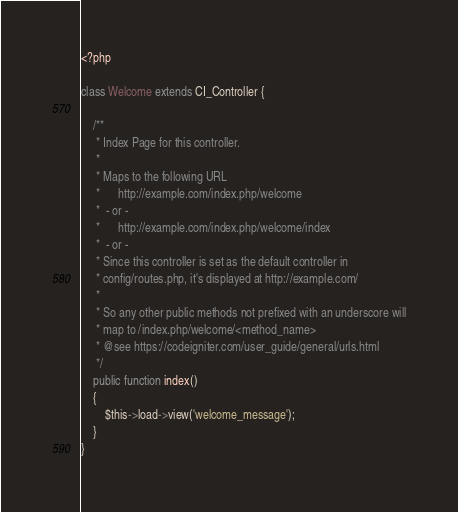<code> <loc_0><loc_0><loc_500><loc_500><_PHP_><?php

class Welcome extends CI_Controller {

	/**
	 * Index Page for this controller.
	 *
	 * Maps to the following URL
	 * 		http://example.com/index.php/welcome
	 *	- or -
	 * 		http://example.com/index.php/welcome/index
	 *	- or -
	 * Since this controller is set as the default controller in
	 * config/routes.php, it's displayed at http://example.com/
	 *
	 * So any other public methods not prefixed with an underscore will
	 * map to /index.php/welcome/<method_name>
	 * @see https://codeigniter.com/user_guide/general/urls.html
	 */
	public function index()
	{
		$this->load->view('welcome_message');
	}
}
</code> 